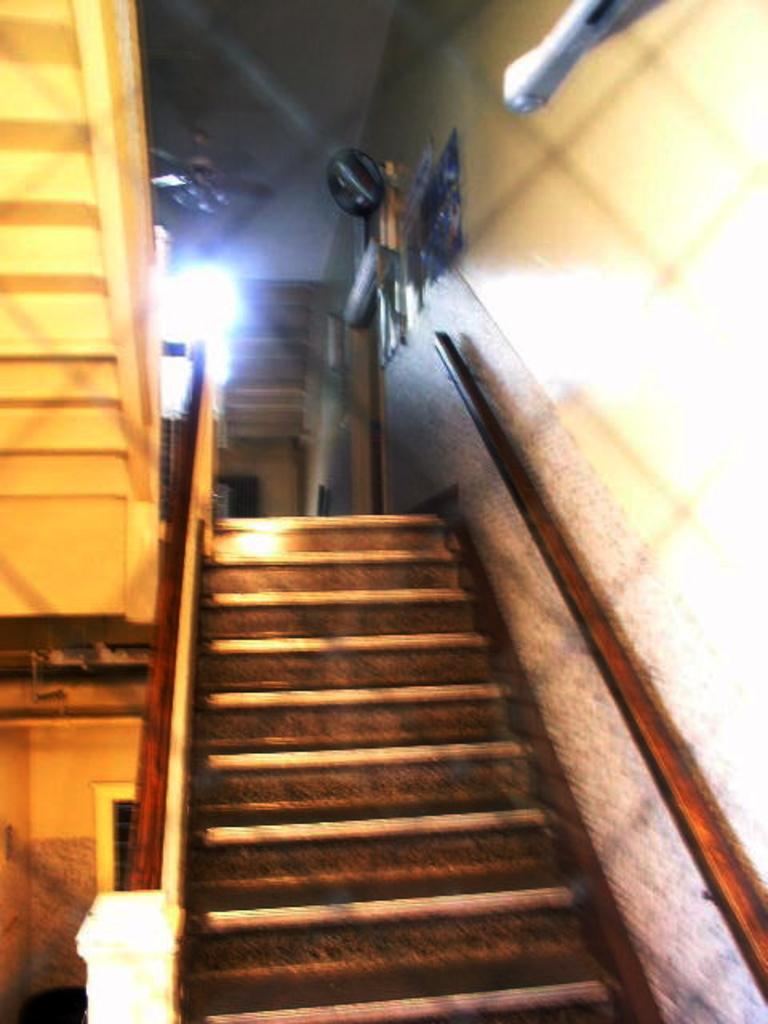What is the main feature in the center of the image? There are stairs in the center of the image. What can be seen on the wall in the background? There are objects on the wall in the background. What is used for air circulation in the image? There is a fan visible in the image. What is used for illumination in the image? There is a light in the image. What allows natural light to enter the space in the image? There is a window in the image. What type of fowl can be seen walking on the stairs in the image? There are no fowl present in the image, and the stairs are stationary. 